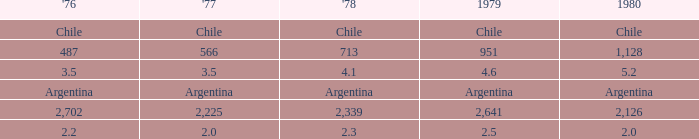What is 1976 when 1980 is 2.0? 2.2. Would you be able to parse every entry in this table? {'header': ["'76", "'77", "'78", '1979', '1980'], 'rows': [['Chile', 'Chile', 'Chile', 'Chile', 'Chile'], ['487', '566', '713', '951', '1,128'], ['3.5', '3.5', '4.1', '4.6', '5.2'], ['Argentina', 'Argentina', 'Argentina', 'Argentina', 'Argentina'], ['2,702', '2,225', '2,339', '2,641', '2,126'], ['2.2', '2.0', '2.3', '2.5', '2.0']]} 